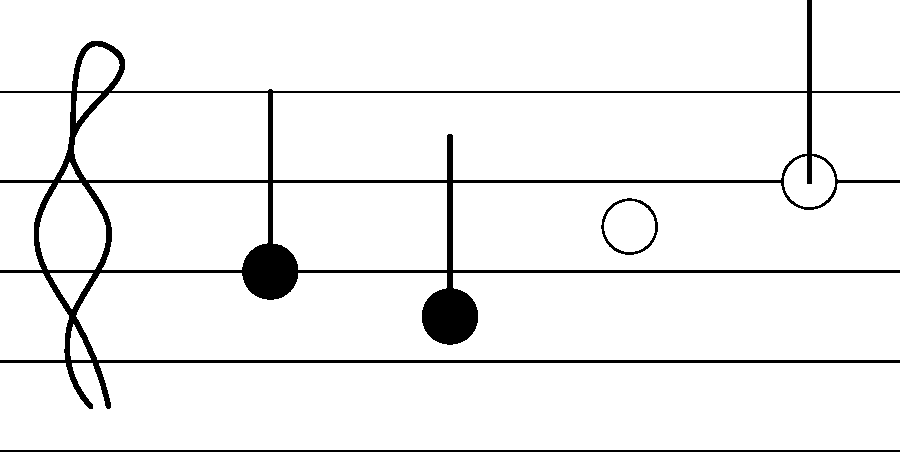Identify the note values of the four notes shown on the staff, from left to right. Express your answer as a sequence of fractions, where 1 represents a whole note. To identify the note values, we need to analyze each note's appearance:

1. First note (leftmost):
   - Filled notehead with a stem
   - This represents a quarter note (1/4 of a whole note)

2. Second note:
   - Filled notehead with a stem
   - This is also a quarter note (1/4 of a whole note)

3. Third note:
   - Open (unfilled) notehead without a stem
   - This represents a half note (1/2 of a whole note)

4. Fourth note (rightmost):
   - Open (unfilled) notehead with a stem
   - This is a whole note (1 whole note)

Therefore, the sequence of note values from left to right is:
$\frac{1}{4}, \frac{1}{4}, \frac{1}{2}, 1$
Answer: $\frac{1}{4}, \frac{1}{4}, \frac{1}{2}, 1$ 